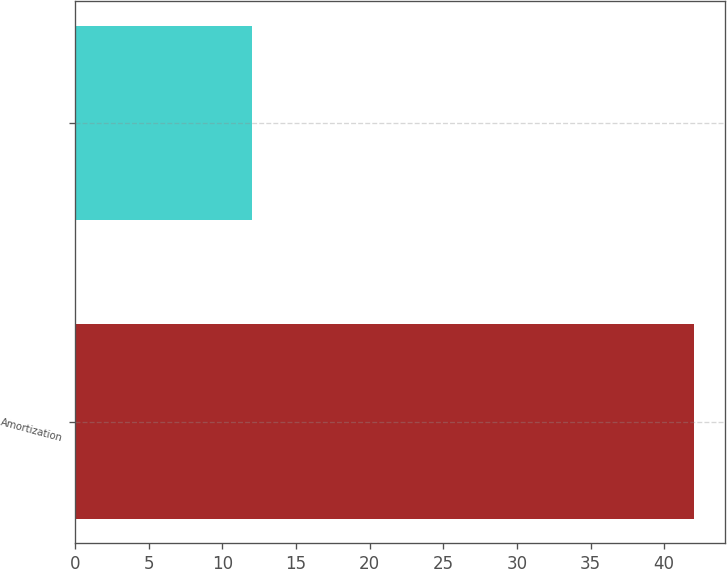Convert chart. <chart><loc_0><loc_0><loc_500><loc_500><bar_chart><fcel>Amortization<fcel>Unnamed: 1<nl><fcel>42<fcel>12<nl></chart> 